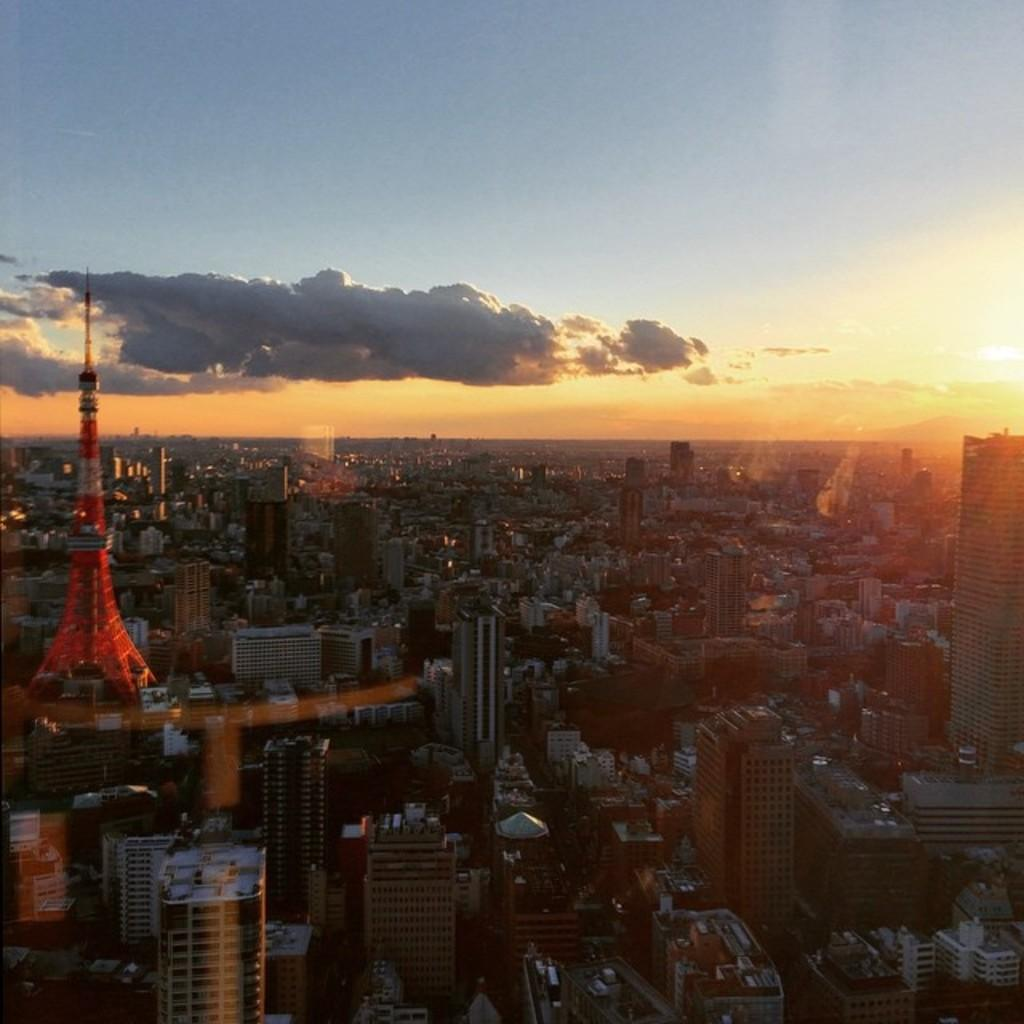What type of view is shown in the image? The image shows a top view of a city. What structures can be seen in the image? There are buildings, houses, and a tower visible in the image. What type of vegetation is present in the image? Trees are present in the image. What is visible at the top of the image? Clouds and the sun are visible at the top of the image. What is the color of the sky in the image? The sky is blue in the image. What type of shop can be seen in the image? There is no shop visible in the image; it shows a top view of a city with various structures and elements. What surprise can be seen in the image? There is no surprise present in the image; it is a straightforward top view of a city. 